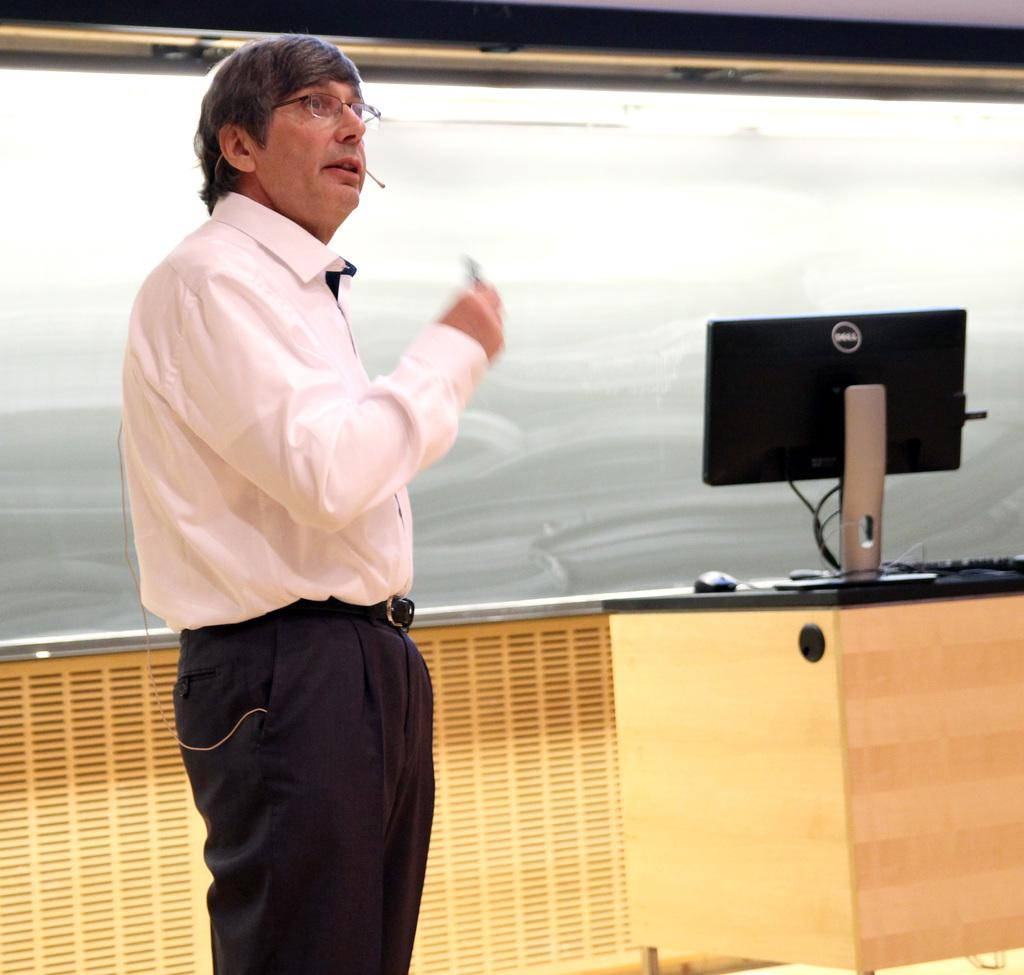What is the main subject in the image? There is a man standing in the image. Can you describe the man's appearance? The man is wearing spectacles. What objects are on the table in the image? There is a monitor, a keyboard, and a mouse on the table. What is the limit of the drain in the image? There is no drain present in the image. 